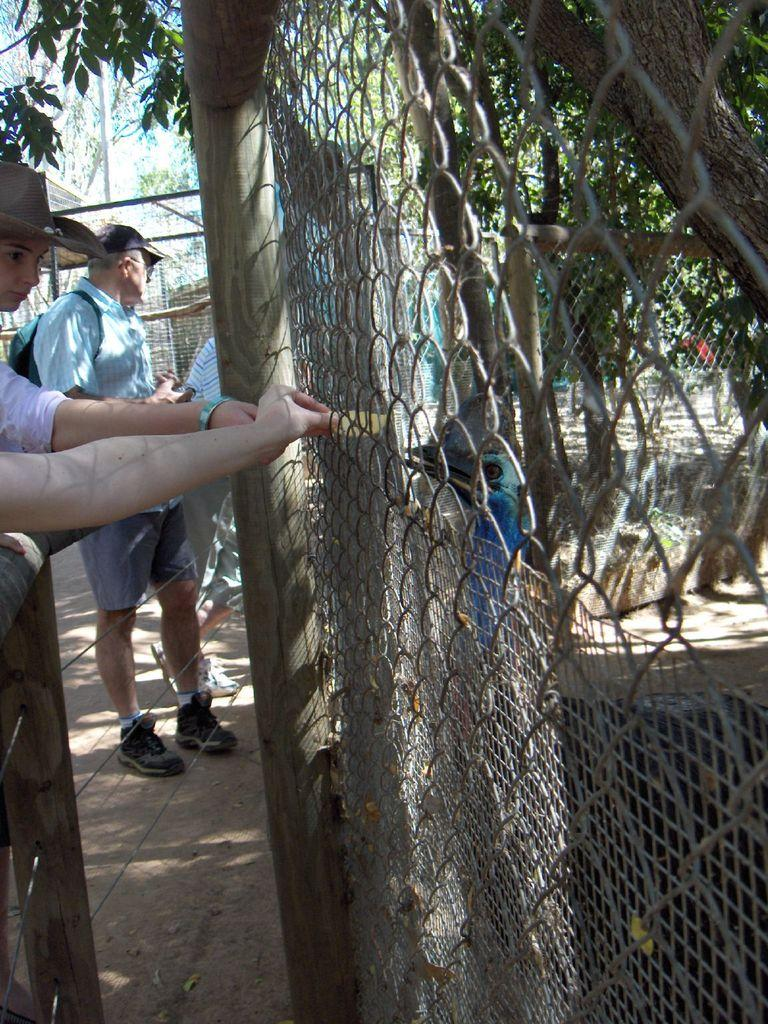What can be seen in the image involving people? There are people standing in the image. What object related to sports or games is present in the image? There is a fencing sheet in the image. What type of animal is visible in the image? There is a bird in the image. Where is a person's hand located in the image? There is a person's hand on the left side of the image. What type of vegetation can be seen in the image? There are trees in the image. What color is the balloon being held by the person in the image? There is no balloon present in the image. What type of farming equipment is being used by the person in the image? There is no farming equipment or yoke present in the image. What type of glove is being worn by the person in the image? There is no glove present in the image. 